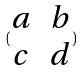<formula> <loc_0><loc_0><loc_500><loc_500>( \begin{matrix} a & b \\ c & d \end{matrix} )</formula> 